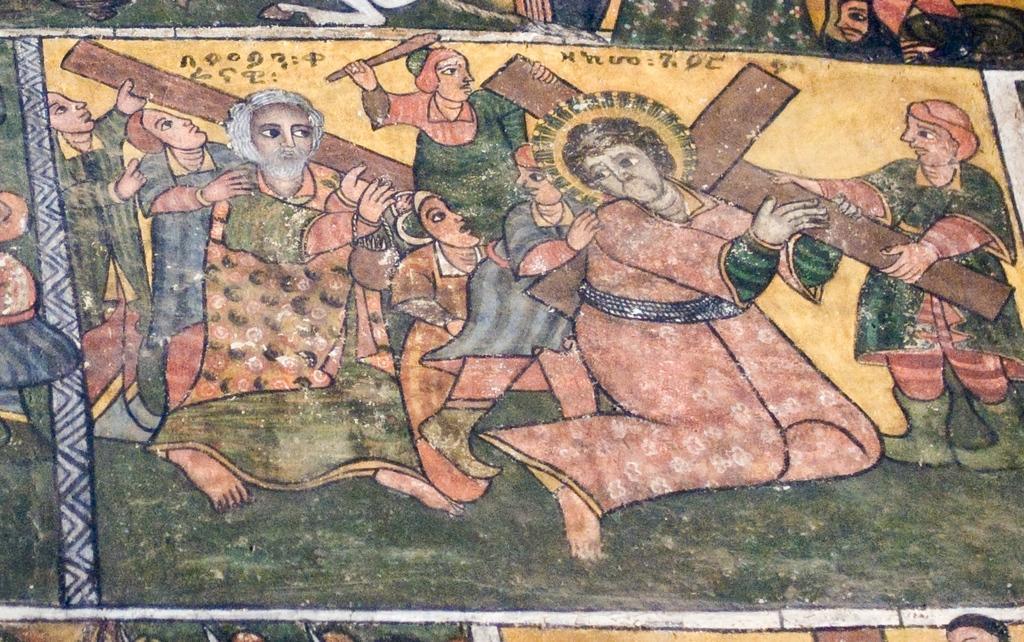How would you summarize this image in a sentence or two? In this image we can see the painting and in the painting we can see some people and among them few people are holding the cross and we can see some text. 